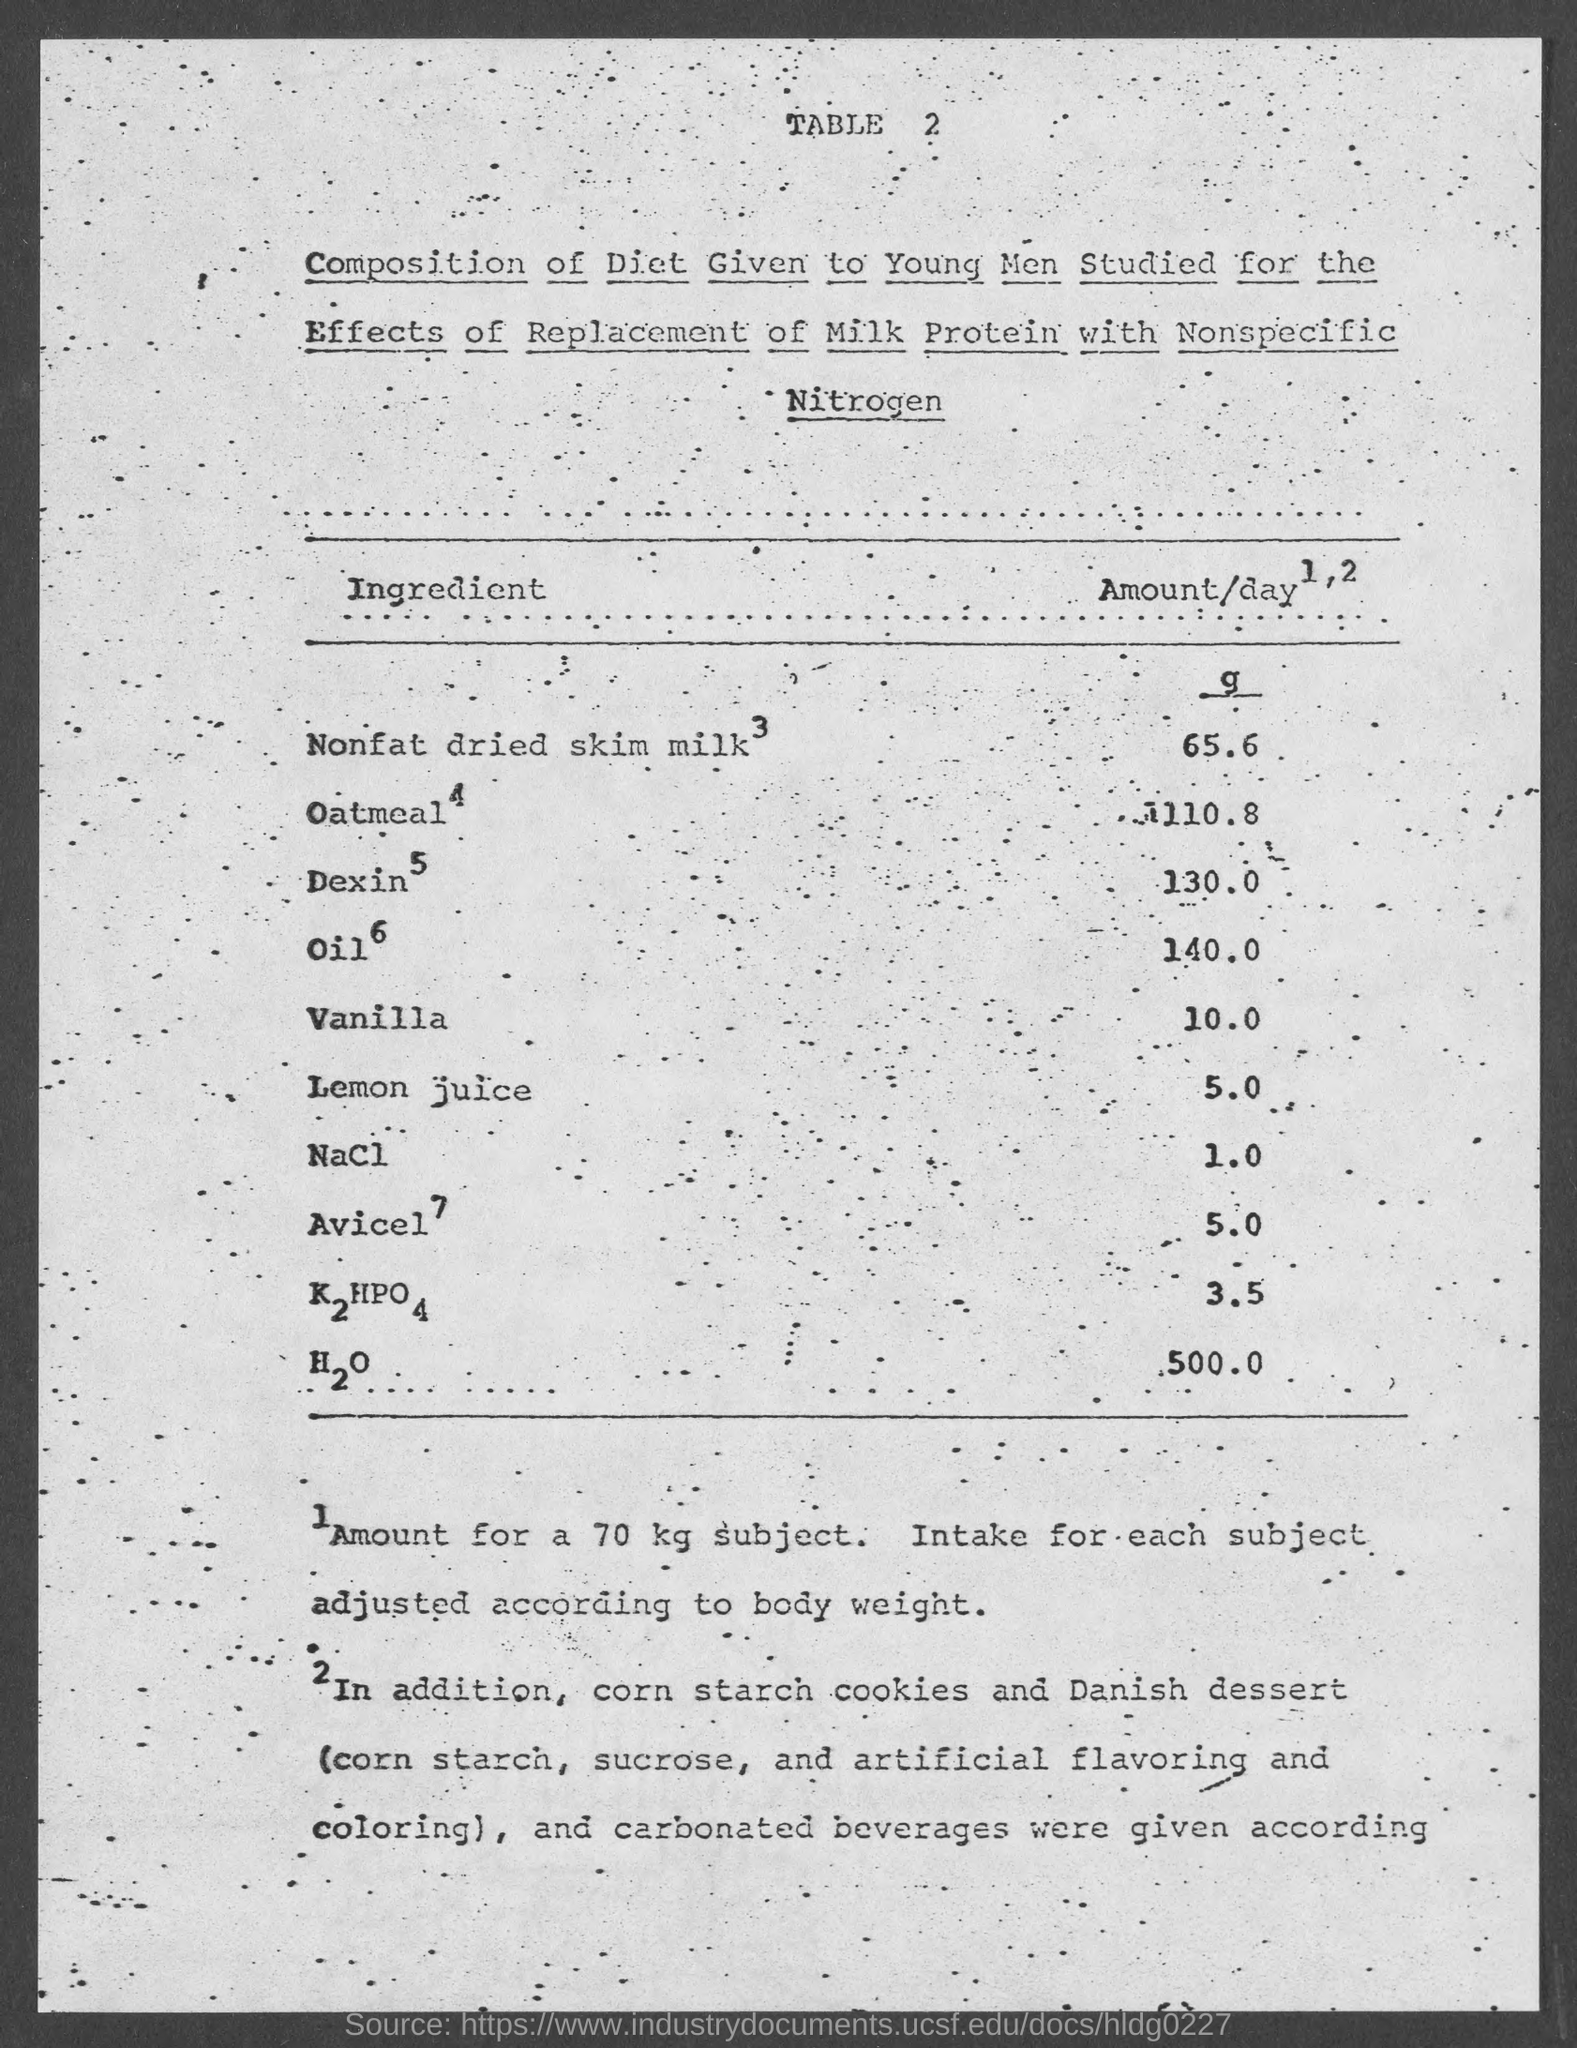Outline some significant characteristics in this image. The table number is 2, and it belongs to Table 2. H2O, the main ingredient present in a large amount. The ingredient present in a small amount is sodium chloride. The amount of sodium chloride is 1.0. The amount of H2O is 500.0... 